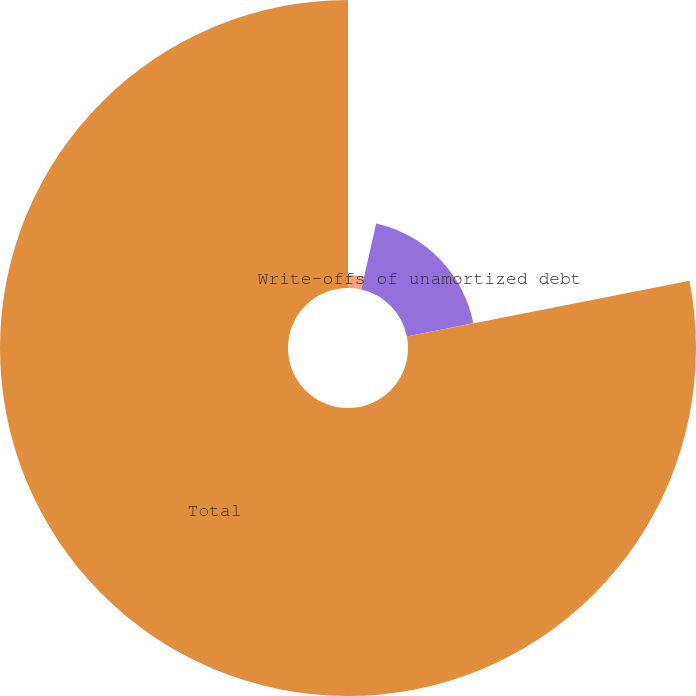<chart> <loc_0><loc_0><loc_500><loc_500><pie_chart><fcel>(In thousands)<fcel>Write-offs of unamortized debt<fcel>Total<nl><fcel>3.54%<fcel>18.37%<fcel>78.09%<nl></chart> 